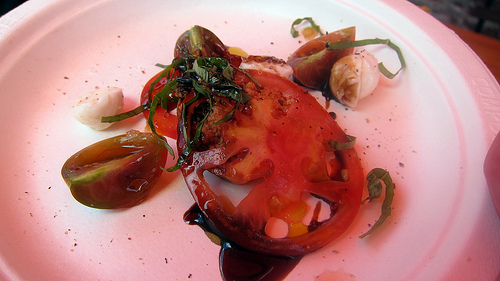<image>
Can you confirm if the basil is on the tomato? Yes. Looking at the image, I can see the basil is positioned on top of the tomato, with the tomato providing support. Is the tomato on the sauce? Yes. Looking at the image, I can see the tomato is positioned on top of the sauce, with the sauce providing support. 